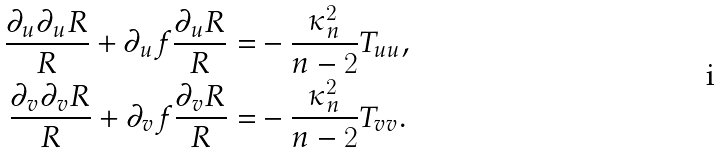Convert formula to latex. <formula><loc_0><loc_0><loc_500><loc_500>\frac { \partial _ { u } \partial _ { u } R } { R } + \partial _ { u } f \frac { \partial _ { u } R } { R } = & - \frac { \kappa _ { n } ^ { 2 } } { n - 2 } T _ { u u } , \\ \frac { \partial _ { v } \partial _ { v } R } { R } + \partial _ { v } f \frac { \partial _ { v } R } { R } = & - \frac { \kappa _ { n } ^ { 2 } } { n - 2 } T _ { v v } .</formula> 